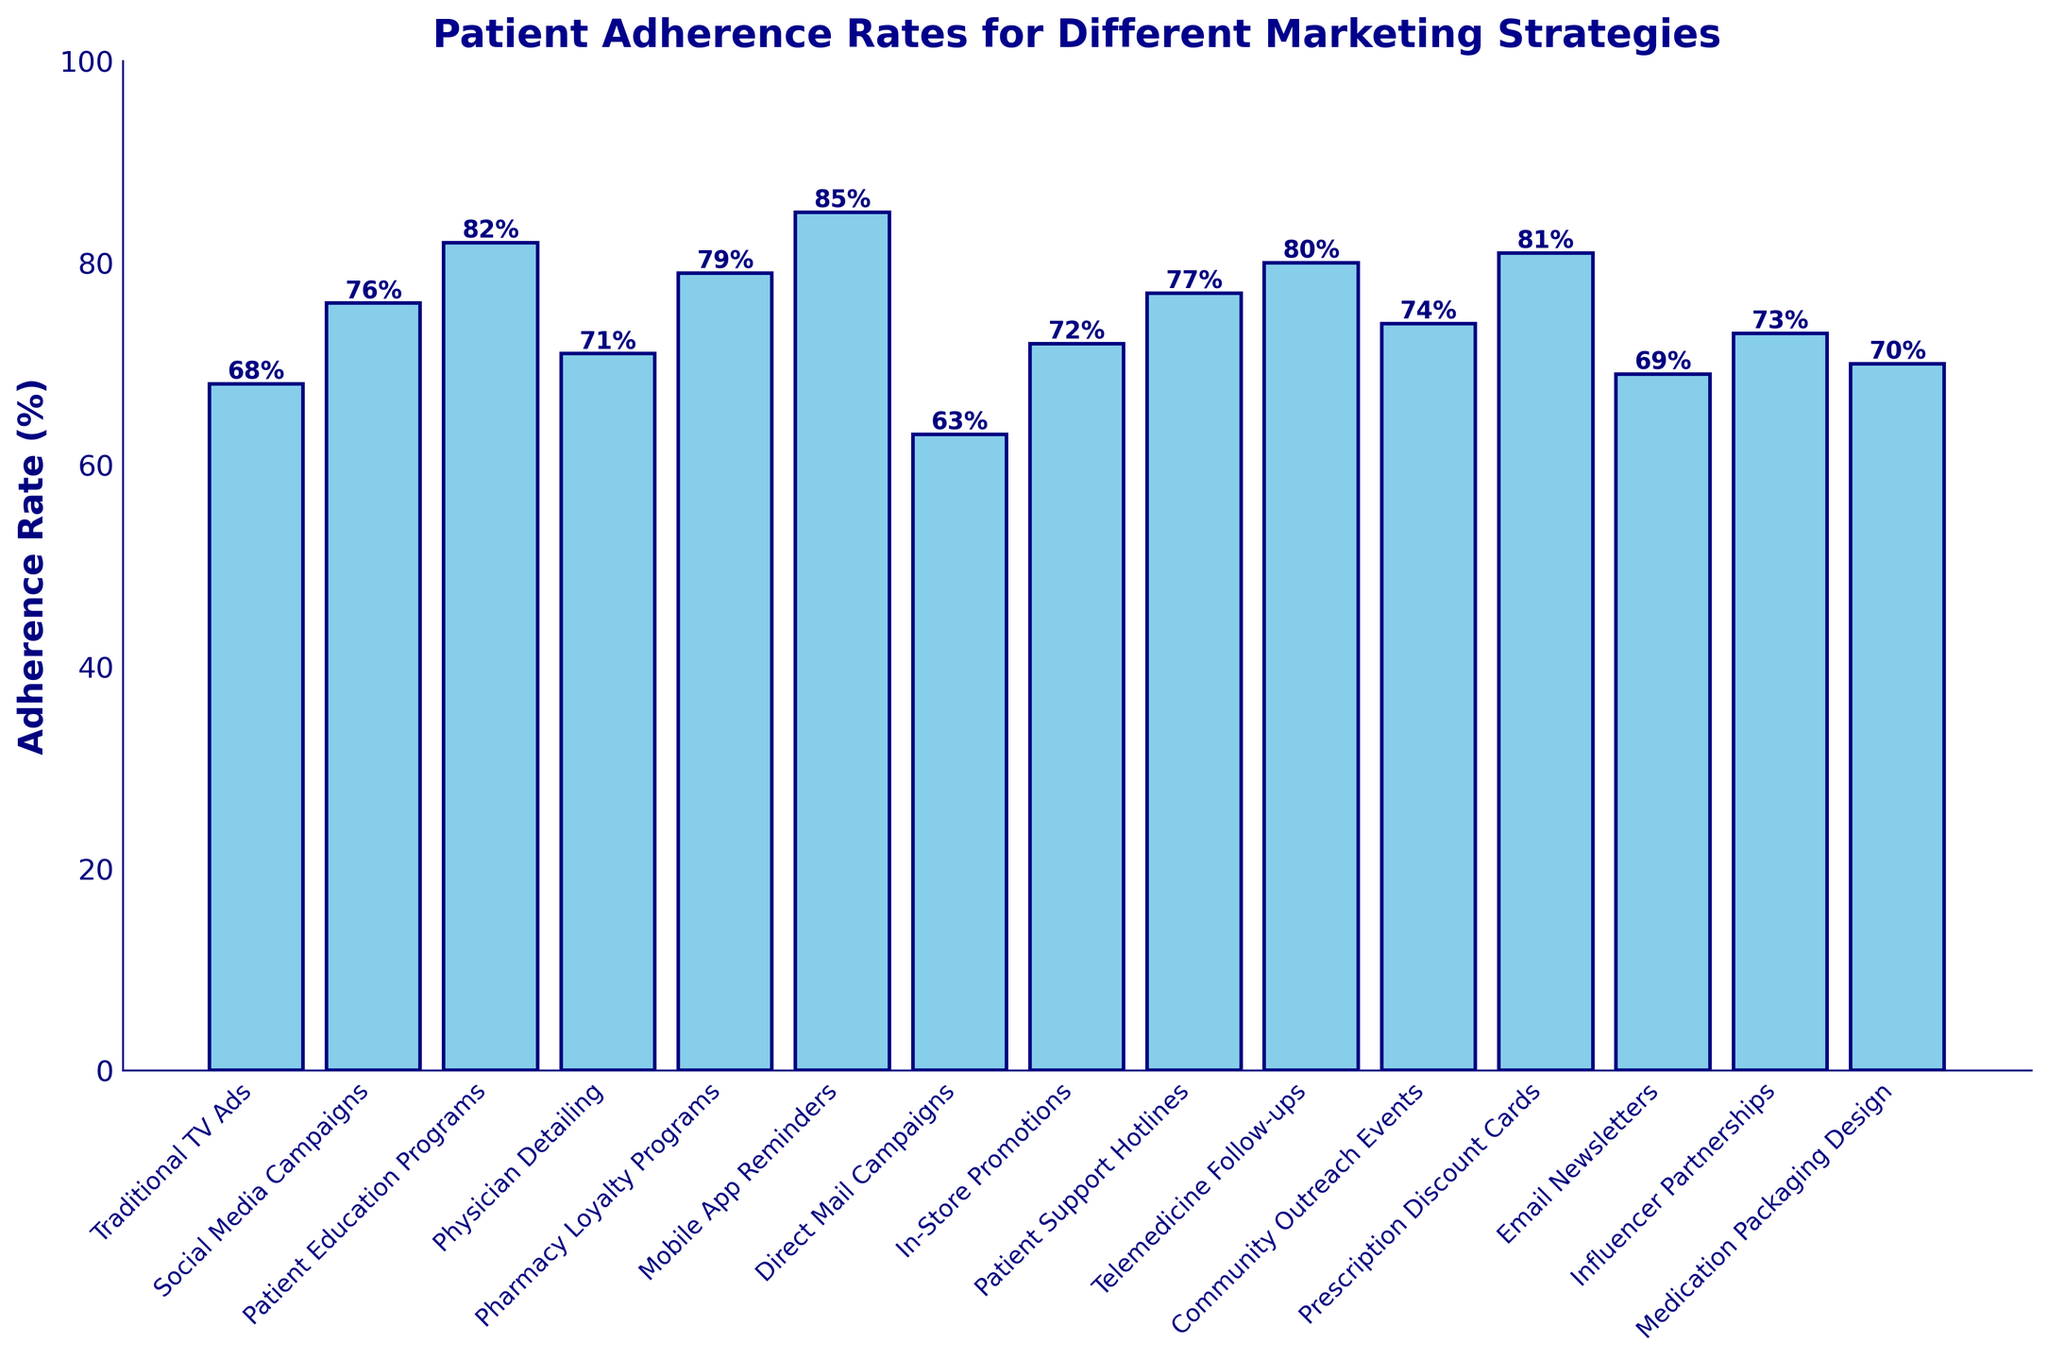What's the highest adherence rate and which marketing strategy does it correspond to? The bar with the greatest height corresponds to the highest adherence rate. By examining the heights of the bars in the figure, the tallest bar represents Mobile App Reminders with an adherence rate of 85%.
Answer: 85%, Mobile App Reminders What's the difference in adherence rate between Traditional TV Ads and Social Media Campaigns? Identify the adherence rates for both strategies from the bar chart; Traditional TV Ads have a rate of 68%, and Social Media Campaigns have 76%. The difference is calculated as 76% - 68%.
Answer: 8% Which marketing strategies have adherence rates equal to or above 80%? Look at the bars that reach or exceed the 80% mark on the y-axis. These strategies are Patient Education Programs (82%), Mobile App Reminders (85%), Telemedicine Follow-ups (80%), and Prescription Discount Cards (81%).
Answer: Patient Education Programs, Mobile App Reminders, Telemedicine Follow-ups, Prescription Discount Cards What's the average adherence rate of the strategies crossing the 75% mark? Identify the adherence rates from the bar chart that are 75% or above: Social Media Campaigns (76%), Pharmacy Loyalty Programs (79%), Patient Support Hotlines (77%), Telemedicine Follow-ups (80%), Prescription Discount Cards (81%), Mobile App Reminders (85%). Sum these rates: 76% + 79% + 77% + 80% + 81% + 85% = 478%. There are 6 strategies, so divide the sum by 6.
Answer: 79.67% Which strategy has a lower adherence rate: Email Newsletters or In-Store Promotions? Compare the heights of the bars for Email Newsletters and In-Store Promotions. Email Newsletters have an adherence rate of 69%, while In-Store Promotions have a rate of 72%. Therefore, Email Newsletters have a lower adherence rate.
Answer: Email Newsletters What's the adherence rate for the strategy with the third highest value, and what is that strategy? Rank the bars by height and identify the third highest bar. The first and second highest are Mobile App Reminders (85%) and Patient Education Programs (82%). The third highest is Prescription Discount Cards with an adherence rate of 81%.
Answer: 81%, Prescription Discount Cards How much higher is the adherence rate of Patient Education Programs compared to Traditional TV Ads? Identify the adherence rates for both strategies from the bar chart: Patient Education Programs (82%) and Traditional TV Ads (68%). The difference is 82% - 68%.
Answer: 14% Among the strategies listed, which one has the lowest adherence rate? Locate the bar with the shortest height. Direct Mail Campaigns have the shortest bar, indicating an adherence rate of 63%.
Answer: Direct Mail Campaigns 